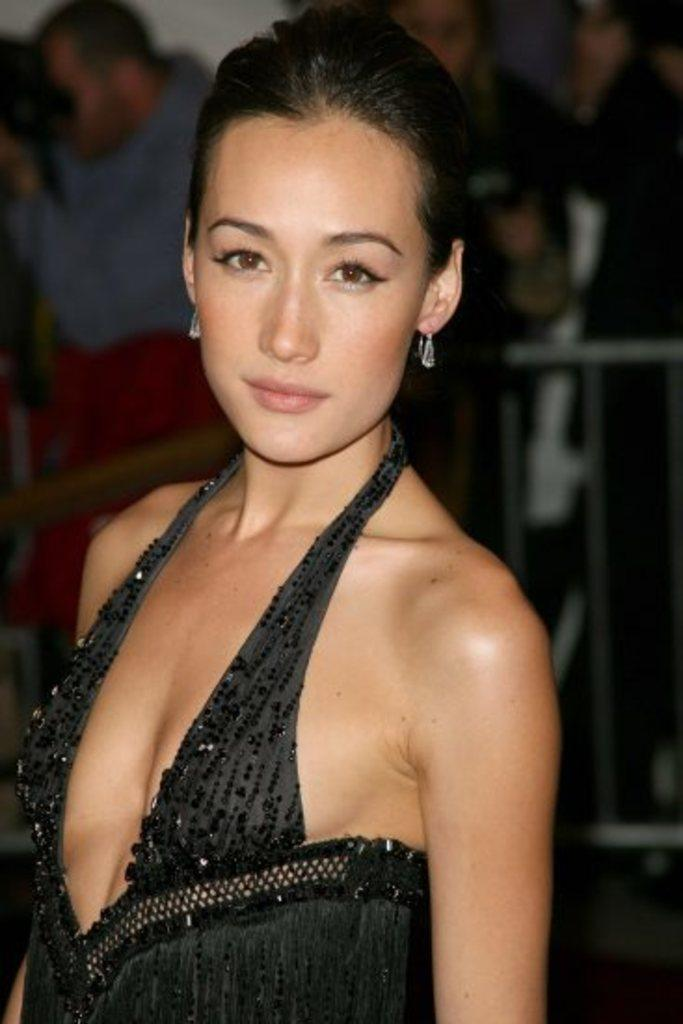What is the woman in the image wearing? The woman is wearing a black dress in the image. How is the woman described in the image? The woman is described as stunning. What can be seen in the background of the image? There is a group of people in the background of the image. What feature is visible in the image that might be used for support or safety? There is a railing visible in the image. How many trucks are parked near the woman in the image? There are no trucks visible in the image. What type of comfort can be found in the chalk used by the woman in the image? There is no chalk present in the image, and the woman is not using any chalk. 